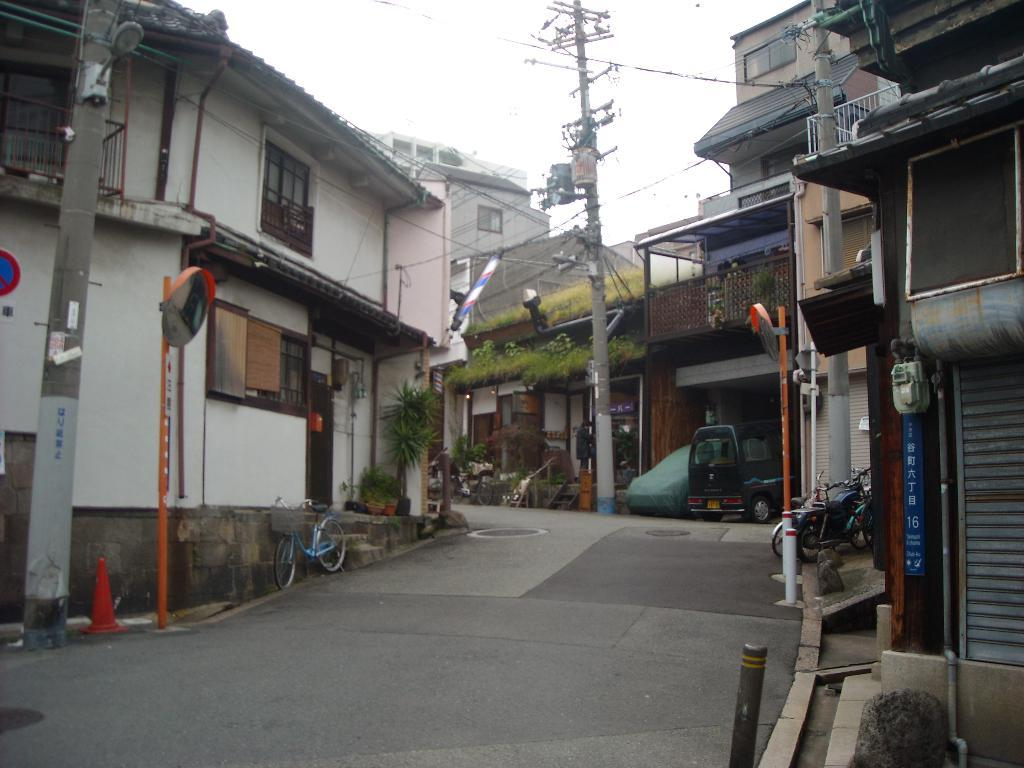What type of area is depicted in the image? The image appears to depict a colony or residential area. How are the houses and buildings arranged in the area? The houses and buildings are situated around a road. What can be seen on the right side of the image? There are two vehicles and a current pole visible on the right side of the image. Can you describe any other objects present in the image? There are other unspecified objects present in the image. How many wristwatches are visible on the people in the image? There are no people visible in the image, so it is impossible to determine the number of wristwatches present. What type of trucks can be seen in the image? There are no trucks visible in the image. 